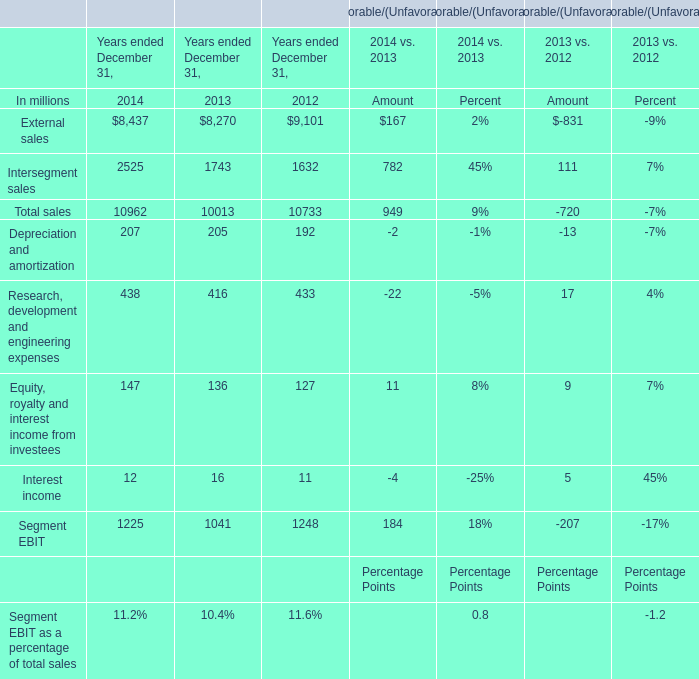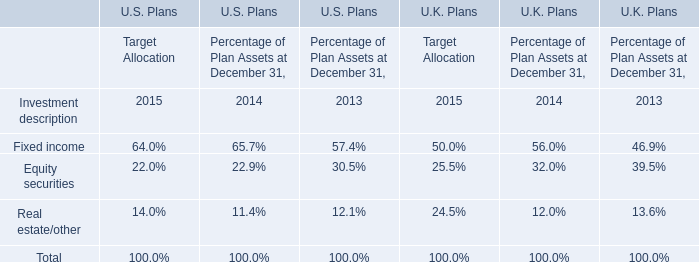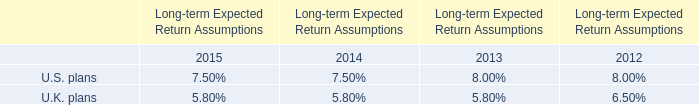What is the total value of External sales, Intersegment sales, Depreciation and amortization and Research, development and engineering expenses in 2014? (in million) 
Computations: (((8437 + 2525) + 207) + 438)
Answer: 11607.0. 